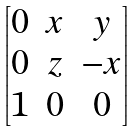Convert formula to latex. <formula><loc_0><loc_0><loc_500><loc_500>\begin{bmatrix} 0 & x & y \\ 0 & z & - x \\ 1 & 0 & 0 \end{bmatrix}</formula> 